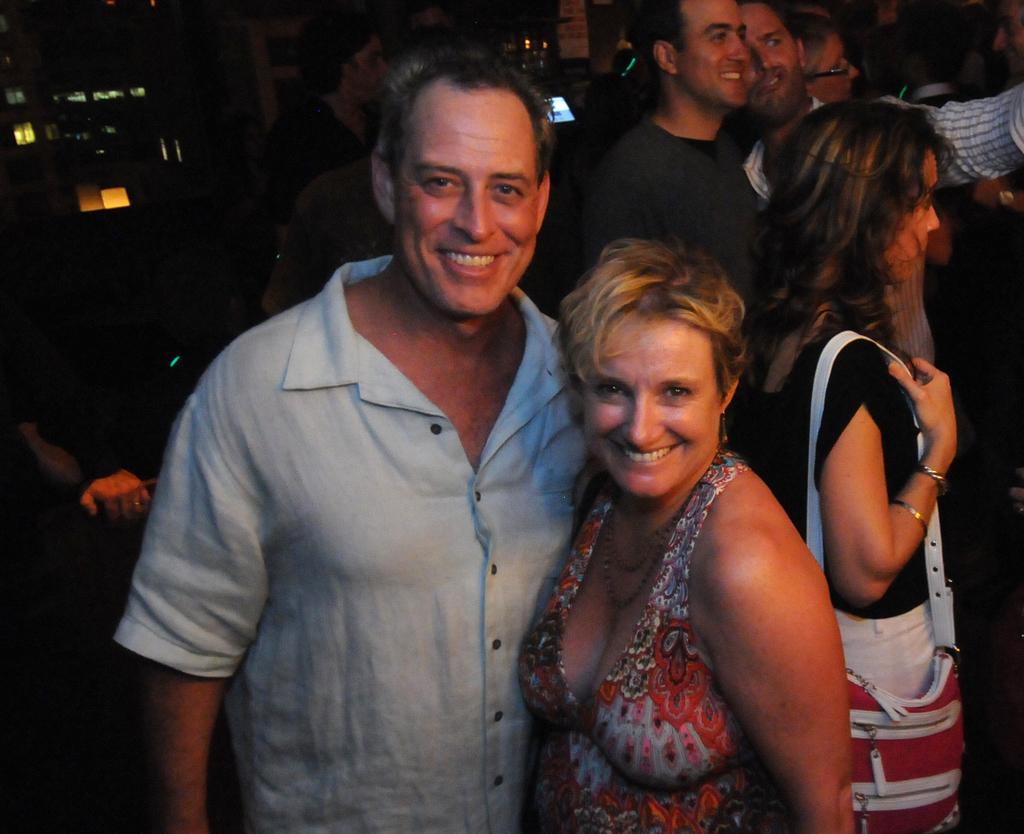What is happening in the image? There are people standing in the image. Can you describe the two individuals in the foreground? A man and a woman are standing in the foreground. What expressions do the man and woman have? The man and woman are smiling. How would you describe the overall lighting in the image? The background of the image is dark. How many snails can be seen crawling on the man's shoulder in the image? There are no snails visible in the image. What type of day is it in the image? The provided facts do not mention the time of day or any specific event, so it cannot be determined if it is a birthday or any other type of day. 